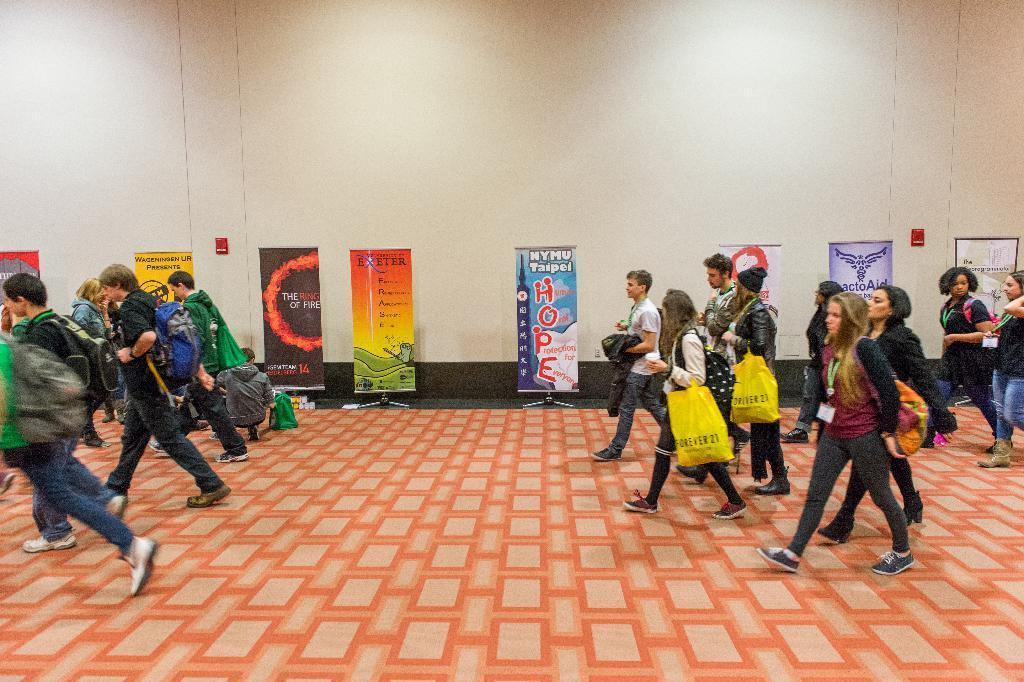Can you describe this image briefly? In the center of the image there are people walking on the floor. In the background of the image there is wall. There are advertisement banners. 